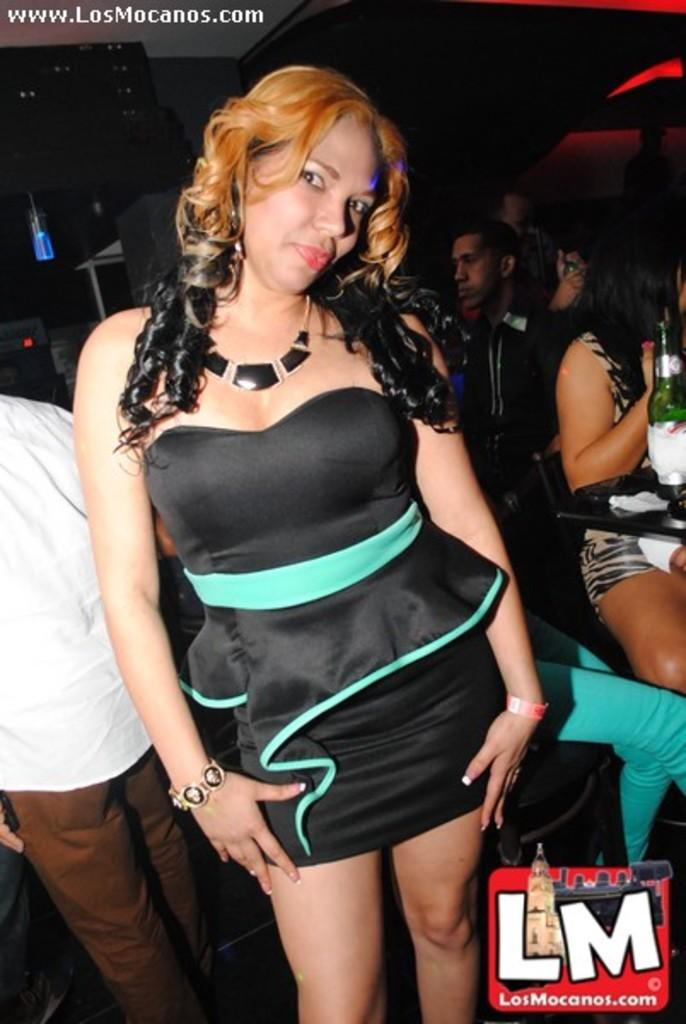Provide a one-sentence caption for the provided image. A woman posing for the camera for LosMocanos.com. 